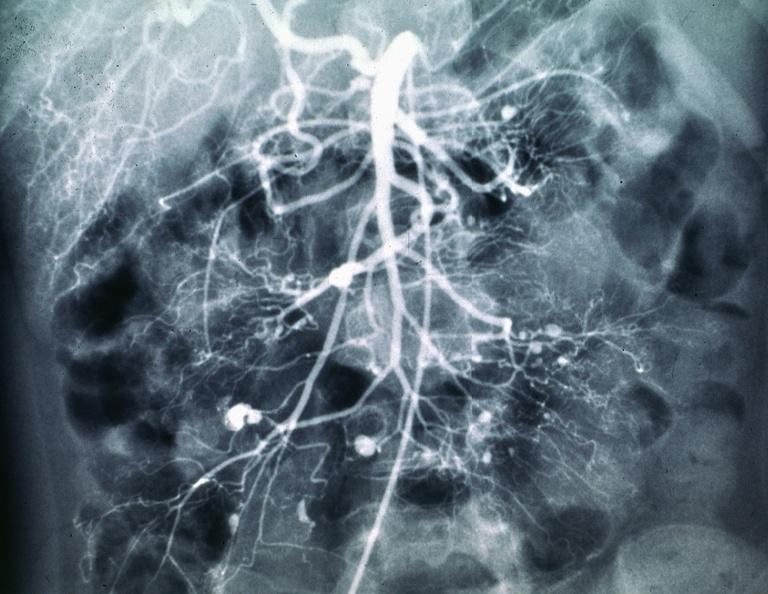where is this area in the body?
Answer the question using a single word or phrase. Abdomen 